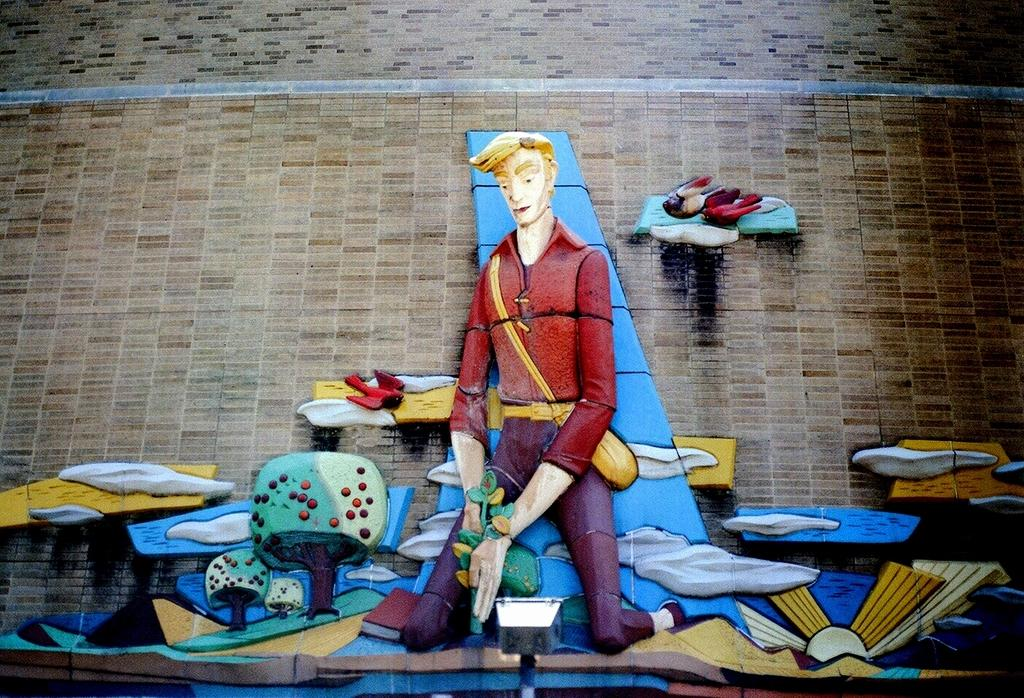What is on the wall in the image? There is an art piece on the wall. What is shown in the art piece? There is a person depicted in the art. What colors are used in the art piece? Red, yellow, blue, and green colors are present in the art. What color is the wall on which the art piece is hung? The wall is in a cream color. What type of skin condition can be seen on the person in the art piece? There is no indication of a skin condition in the image, as it only shows an art piece with a person depicted. 